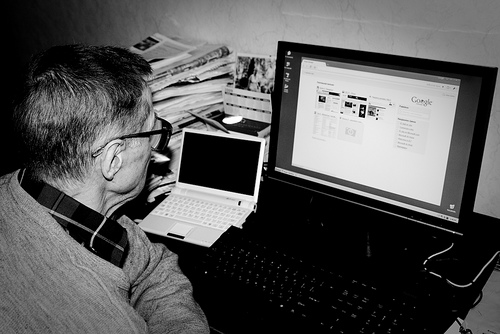Please identify all text content in this image. Google 